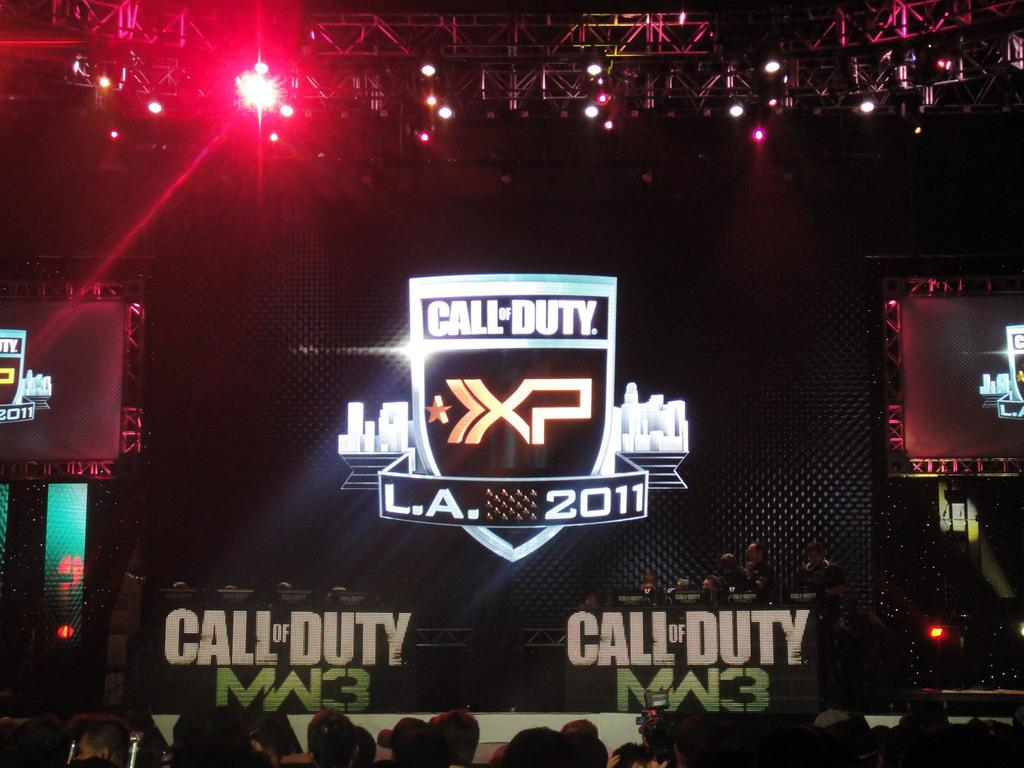Provide a one-sentence caption for the provided image. An audience sits at a Call of Duty XP convention in L.A 2011. 